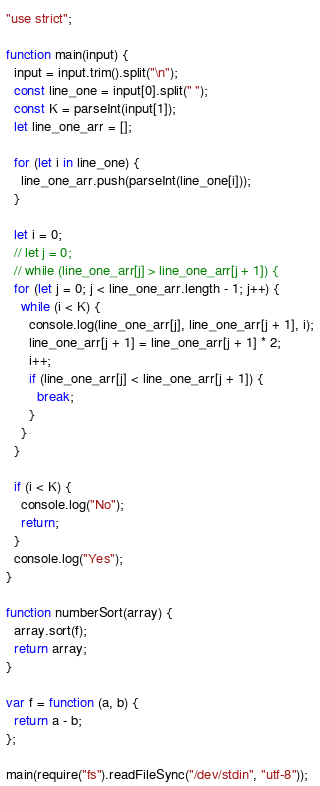<code> <loc_0><loc_0><loc_500><loc_500><_JavaScript_>"use strict";

function main(input) {
  input = input.trim().split("\n");
  const line_one = input[0].split(" ");
  const K = parseInt(input[1]);
  let line_one_arr = [];

  for (let i in line_one) {
    line_one_arr.push(parseInt(line_one[i]));
  }

  let i = 0;
  // let j = 0;
  // while (line_one_arr[j] > line_one_arr[j + 1]) {
  for (let j = 0; j < line_one_arr.length - 1; j++) {
    while (i < K) {
      console.log(line_one_arr[j], line_one_arr[j + 1], i);
      line_one_arr[j + 1] = line_one_arr[j + 1] * 2;
      i++;
      if (line_one_arr[j] < line_one_arr[j + 1]) {
        break;
      }
    }
  }

  if (i < K) {
    console.log("No");
    return;
  }
  console.log("Yes");
}

function numberSort(array) {
  array.sort(f);
  return array;
}

var f = function (a, b) {
  return a - b;
};

main(require("fs").readFileSync("/dev/stdin", "utf-8"));
</code> 